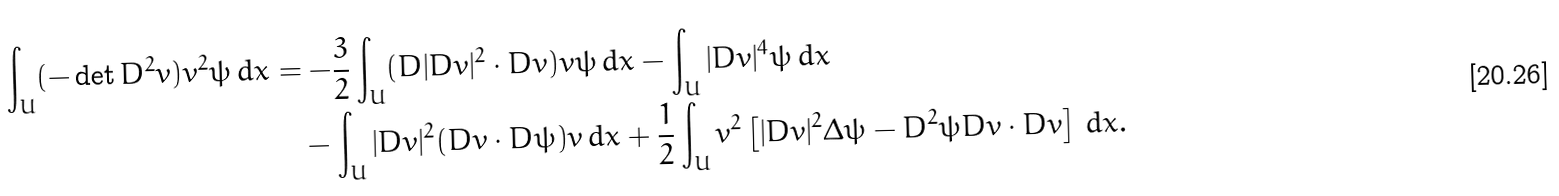Convert formula to latex. <formula><loc_0><loc_0><loc_500><loc_500>\int _ { U } ( - \det D ^ { 2 } v ) v ^ { 2 } \psi \, d x & = - \frac { 3 } { 2 } \int _ { U } ( D | D v | ^ { 2 } \cdot D v ) v \psi \, d x - \int _ { U } | D v | ^ { 4 } \psi \, d x \\ & \quad - \int _ { U } | D v | ^ { 2 } ( D v \cdot D \psi ) v \, d x + \frac { 1 } { 2 } \int _ { U } v ^ { 2 } \left [ | D v | ^ { 2 } \Delta \psi - D ^ { 2 } \psi D v \cdot D v \right ] \, d x .</formula> 